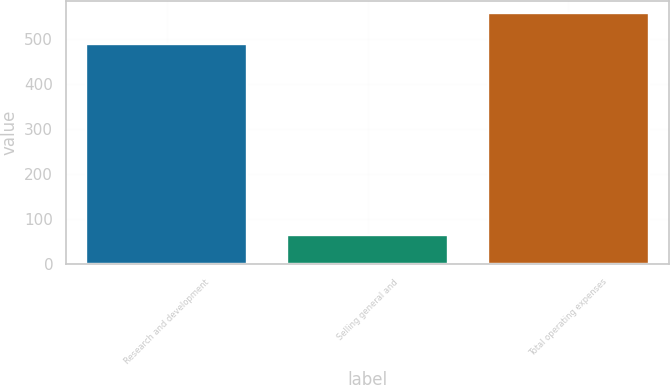Convert chart. <chart><loc_0><loc_0><loc_500><loc_500><bar_chart><fcel>Research and development<fcel>Selling general and<fcel>Total operating expenses<nl><fcel>489.2<fcel>65.2<fcel>556.5<nl></chart> 